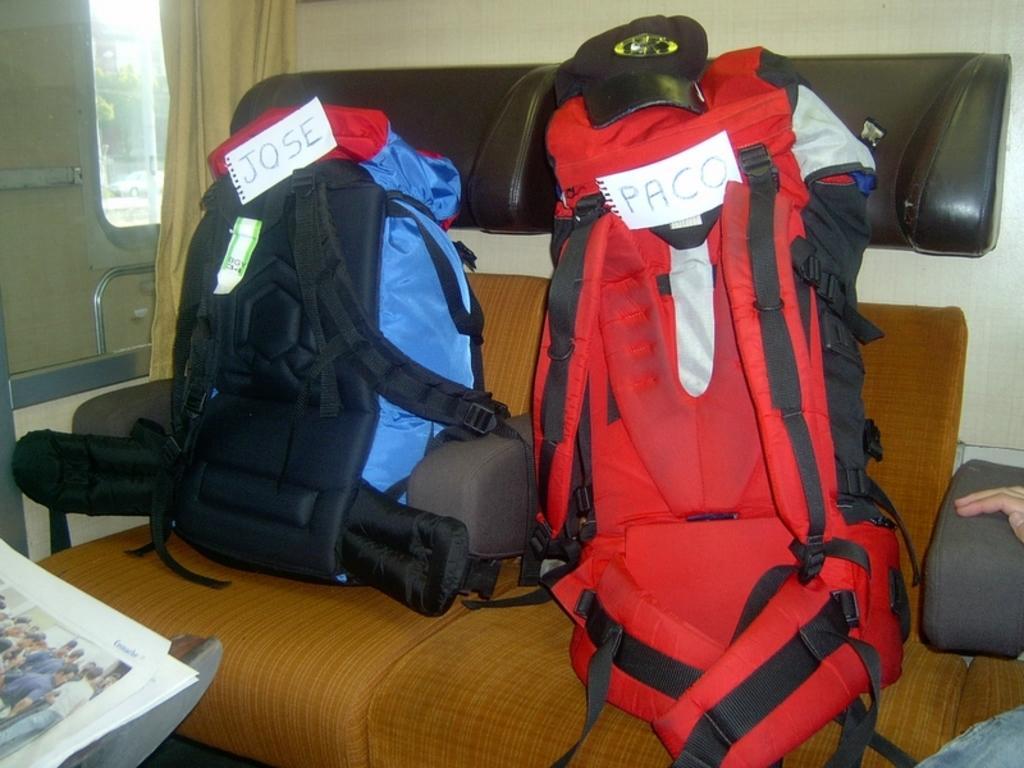Could you give a brief overview of what you see in this image? This is inside view picture of a vehicle. Here we can see a window and a curtain. On the chair we can see two backpacks which is in red and blue black color. This is a newspaper. here we can see partial part of the human hand and leg. 